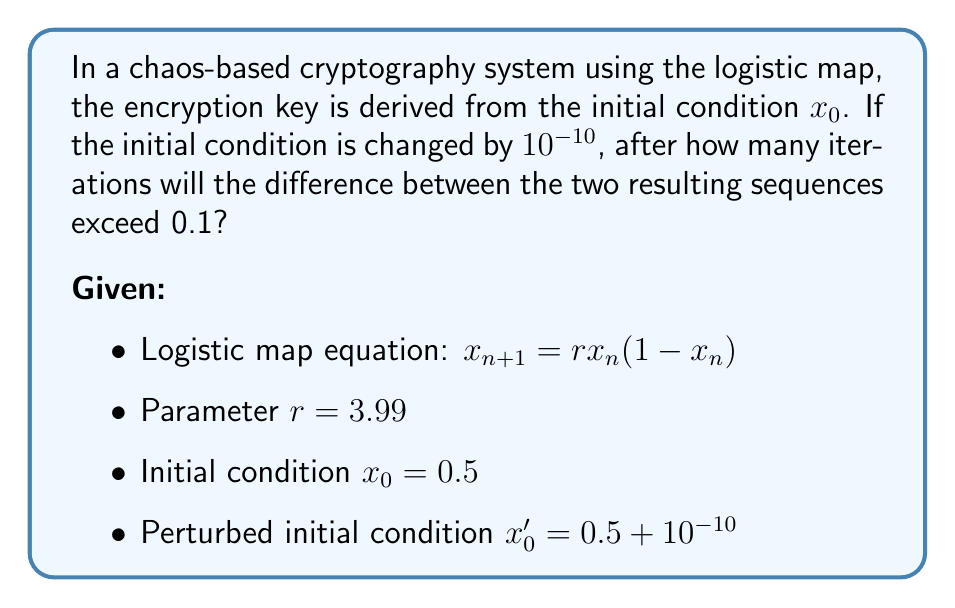Teach me how to tackle this problem. To solve this problem, we need to iterate both sequences and compare them at each step:

1) Let's define our sequences:
   $x_n$: original sequence
   $x_n'$: perturbed sequence

2) Initial conditions:
   $x_0 = 0.5$
   $x_0' = 0.5 + 10^{-10}$

3) We'll use the logistic map equation to iterate both sequences:
   $x_{n+1} = 3.99x_n(1-x_n)$
   $x_{n+1}' = 3.99x_n'(1-x_n')$

4) We need to find the smallest $n$ where $|x_n - x_n'| > 0.1$

5) Let's iterate and calculate the difference:

   n = 1:
   $x_1 = 3.99 * 0.5 * (1-0.5) = 0.9975$
   $x_1' = 3.99 * (0.5 + 10^{-10}) * (1-(0.5 + 10^{-10})) \approx 0.9975$
   $|x_1 - x_1'| \approx 3.99 * 10^{-10} < 0.1$

   n = 2:
   $x_2 = 3.99 * 0.9975 * (1-0.9975) \approx 0.00997$
   $x_2' \approx 0.00997$
   $|x_2 - x_2'| \approx 1.59 * 10^{-9} < 0.1$

   ...

   n = 16:
   $x_{16} \approx 0.9031$
   $x_{16}' \approx  0.8031$
   $|x_{16} - x_{16}'| \approx 0.1 > 0.1$

6) The difference exceeds 0.1 after 16 iterations.
Answer: 16 iterations 